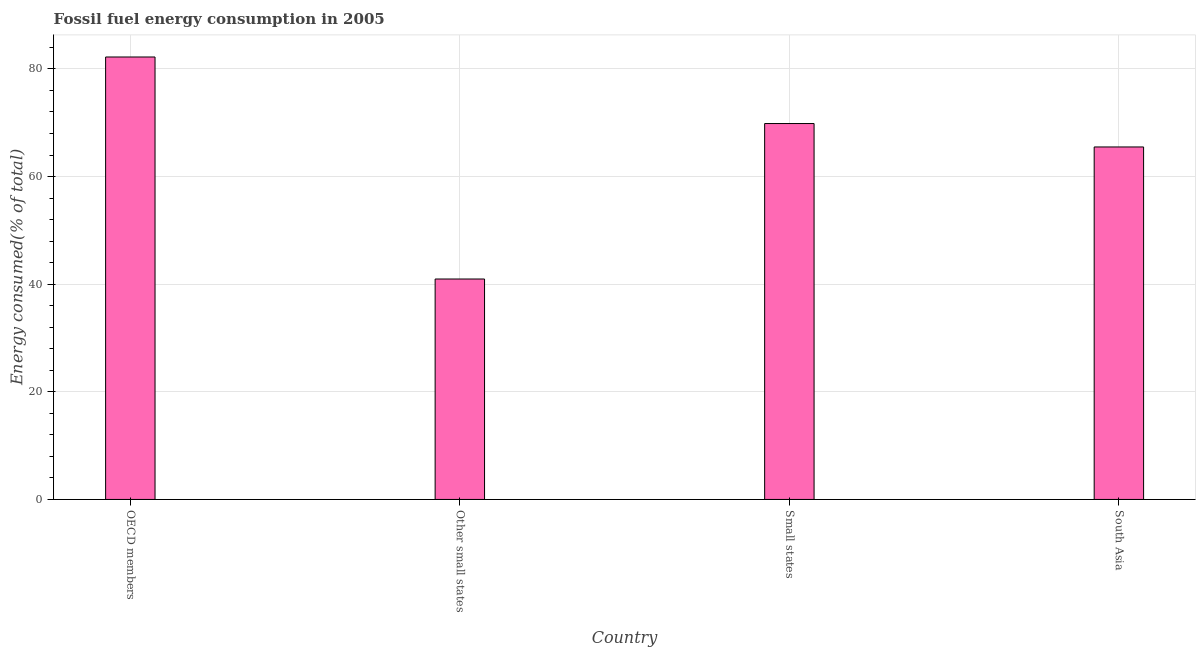What is the title of the graph?
Provide a succinct answer. Fossil fuel energy consumption in 2005. What is the label or title of the Y-axis?
Provide a short and direct response. Energy consumed(% of total). What is the fossil fuel energy consumption in OECD members?
Your response must be concise. 82.21. Across all countries, what is the maximum fossil fuel energy consumption?
Your answer should be very brief. 82.21. Across all countries, what is the minimum fossil fuel energy consumption?
Keep it short and to the point. 40.96. In which country was the fossil fuel energy consumption maximum?
Your answer should be very brief. OECD members. In which country was the fossil fuel energy consumption minimum?
Your answer should be very brief. Other small states. What is the sum of the fossil fuel energy consumption?
Offer a very short reply. 258.52. What is the difference between the fossil fuel energy consumption in OECD members and Other small states?
Make the answer very short. 41.25. What is the average fossil fuel energy consumption per country?
Provide a succinct answer. 64.63. What is the median fossil fuel energy consumption?
Your answer should be very brief. 67.67. What is the ratio of the fossil fuel energy consumption in OECD members to that in South Asia?
Offer a very short reply. 1.25. Is the fossil fuel energy consumption in OECD members less than that in Other small states?
Keep it short and to the point. No. What is the difference between the highest and the second highest fossil fuel energy consumption?
Your response must be concise. 12.36. Is the sum of the fossil fuel energy consumption in Other small states and South Asia greater than the maximum fossil fuel energy consumption across all countries?
Offer a very short reply. Yes. What is the difference between the highest and the lowest fossil fuel energy consumption?
Ensure brevity in your answer.  41.25. In how many countries, is the fossil fuel energy consumption greater than the average fossil fuel energy consumption taken over all countries?
Ensure brevity in your answer.  3. Are all the bars in the graph horizontal?
Ensure brevity in your answer.  No. How many countries are there in the graph?
Give a very brief answer. 4. What is the difference between two consecutive major ticks on the Y-axis?
Provide a succinct answer. 20. What is the Energy consumed(% of total) in OECD members?
Offer a terse response. 82.21. What is the Energy consumed(% of total) of Other small states?
Make the answer very short. 40.96. What is the Energy consumed(% of total) of Small states?
Offer a very short reply. 69.85. What is the Energy consumed(% of total) of South Asia?
Ensure brevity in your answer.  65.5. What is the difference between the Energy consumed(% of total) in OECD members and Other small states?
Give a very brief answer. 41.25. What is the difference between the Energy consumed(% of total) in OECD members and Small states?
Your answer should be compact. 12.36. What is the difference between the Energy consumed(% of total) in OECD members and South Asia?
Offer a terse response. 16.72. What is the difference between the Energy consumed(% of total) in Other small states and Small states?
Provide a short and direct response. -28.89. What is the difference between the Energy consumed(% of total) in Other small states and South Asia?
Your answer should be very brief. -24.54. What is the difference between the Energy consumed(% of total) in Small states and South Asia?
Your response must be concise. 4.35. What is the ratio of the Energy consumed(% of total) in OECD members to that in Other small states?
Make the answer very short. 2.01. What is the ratio of the Energy consumed(% of total) in OECD members to that in Small states?
Your answer should be compact. 1.18. What is the ratio of the Energy consumed(% of total) in OECD members to that in South Asia?
Your response must be concise. 1.25. What is the ratio of the Energy consumed(% of total) in Other small states to that in Small states?
Your response must be concise. 0.59. What is the ratio of the Energy consumed(% of total) in Small states to that in South Asia?
Your answer should be compact. 1.07. 